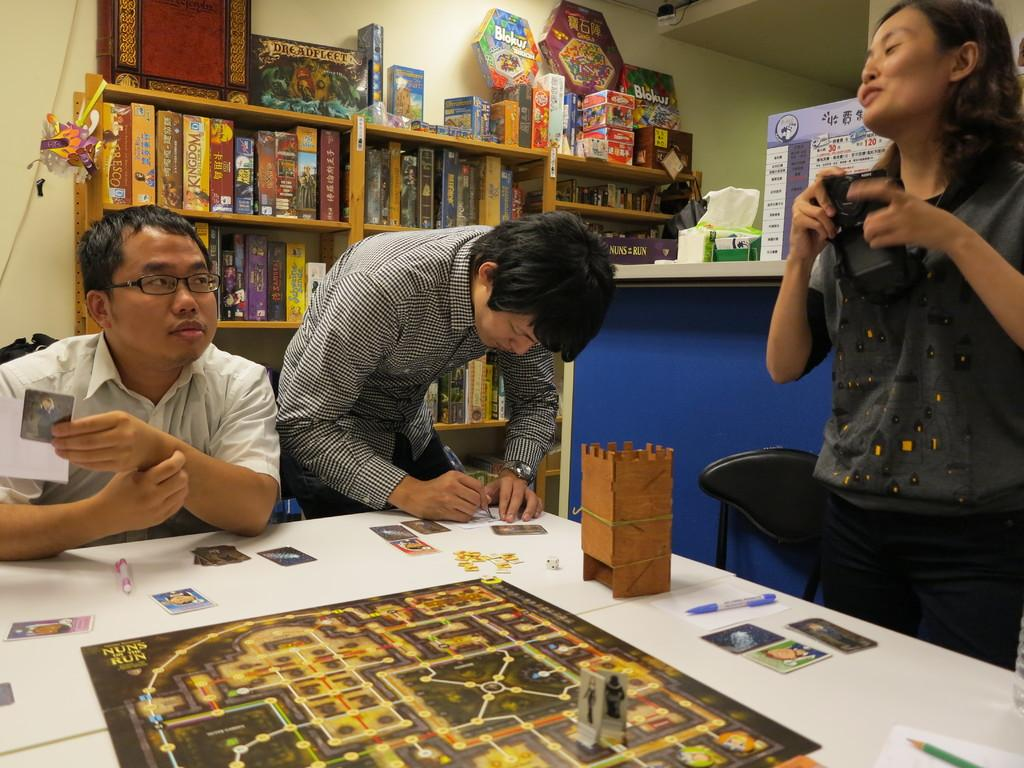How many people are in the image? There are two men and a woman in the image. What is the woman holding in the image? The woman is holding a camera. What activity are the two men engaged in? The two men are playing a game using cards. Where is the game being played? The game is placed on a table. What type of committee is meeting in the image? There is no committee meeting in the image; it features two men playing a game using cards and a woman holding a camera. What type of chess pieces can be seen on the table in the image? There is no chess game present in the image; the game being played is with cards. 